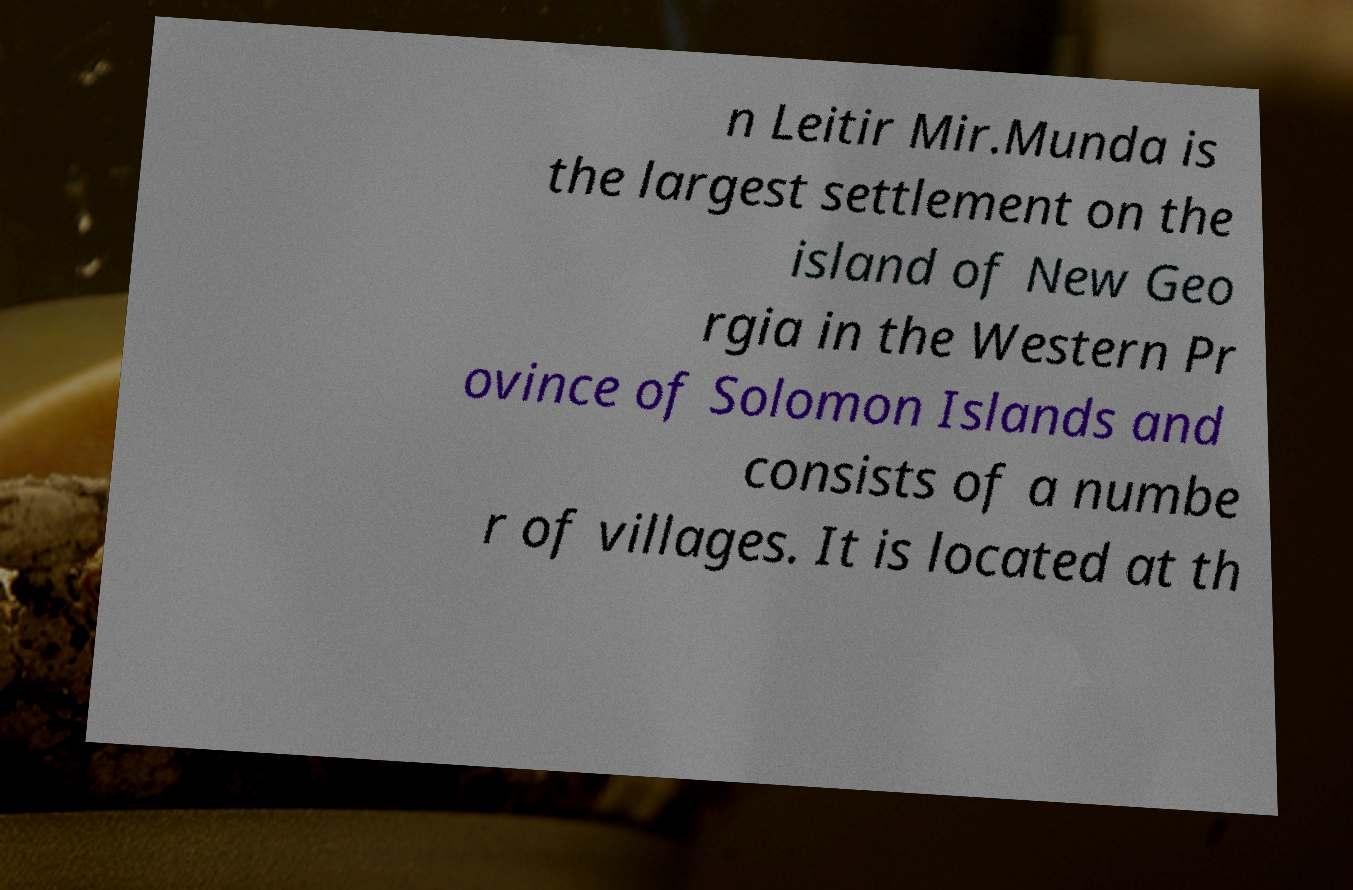There's text embedded in this image that I need extracted. Can you transcribe it verbatim? n Leitir Mir.Munda is the largest settlement on the island of New Geo rgia in the Western Pr ovince of Solomon Islands and consists of a numbe r of villages. It is located at th 